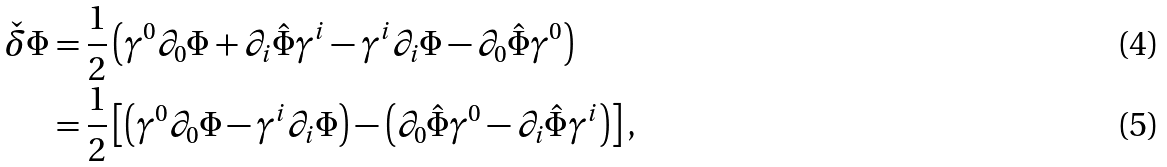<formula> <loc_0><loc_0><loc_500><loc_500>\check { \delta } \Phi & = \frac { 1 } { 2 } \left ( \gamma ^ { 0 } \partial _ { 0 } \Phi + \partial _ { i } \hat { \Phi } \gamma ^ { i } - \gamma ^ { i } \partial _ { i } \Phi - \partial _ { 0 } \hat { \Phi } \gamma ^ { 0 } \right ) \\ & = \frac { 1 } { 2 } \left [ \left ( \gamma ^ { 0 } \partial _ { 0 } \Phi - \gamma ^ { i } \partial _ { i } \Phi \right ) - \left ( \partial _ { 0 } \hat { \Phi } \gamma ^ { 0 } - \partial _ { i } \hat { \Phi } \gamma ^ { i } \right ) \right ] ,</formula> 